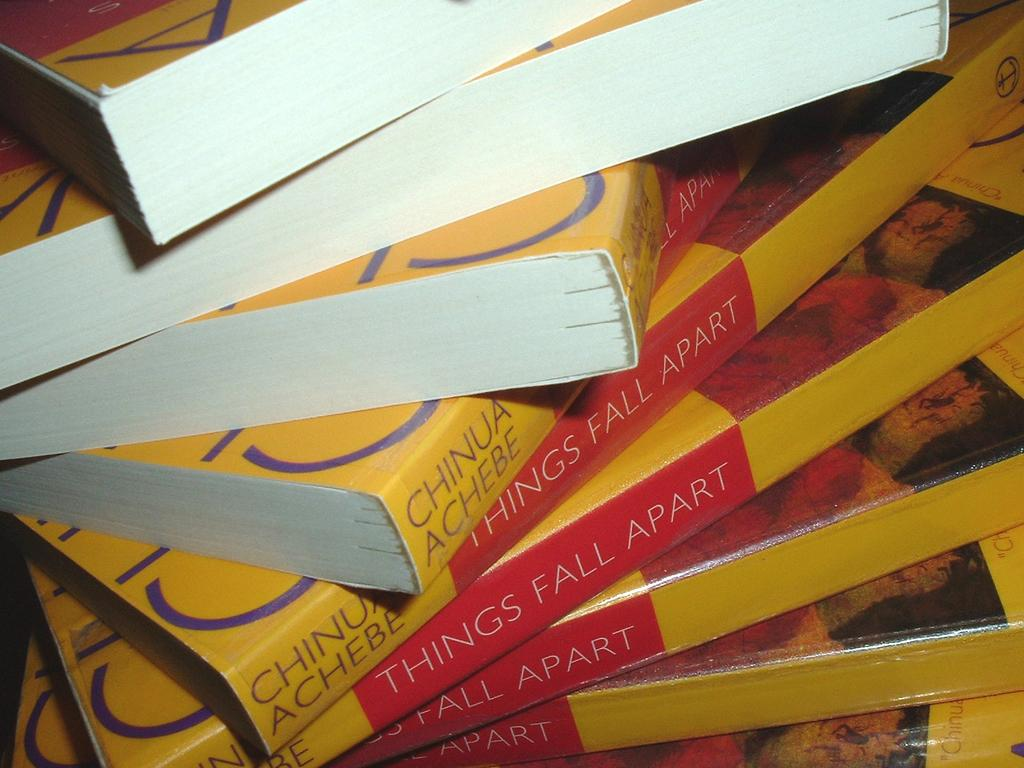Provide a one-sentence caption for the provided image. A stack of identical books by author Chinua Achebe is askew. 